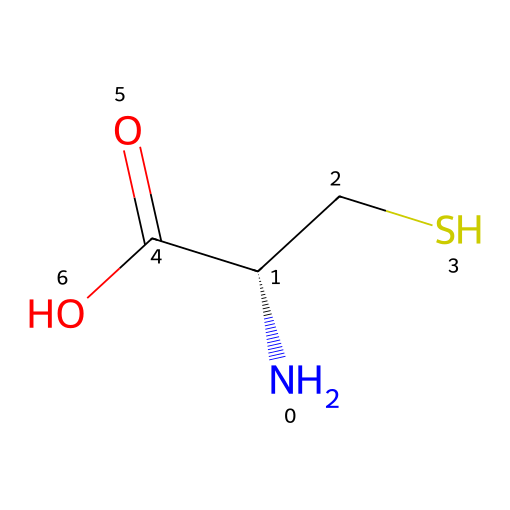How many carbon atoms are present in cysteine? The SMILES representation shows the structure, and by identifying the carbon atoms (C) in the string "N[C@@H](CS)C(=O)O," we can see three distinct carbon atoms present in the structure.
Answer: three What functional groups are present in cysteine? By analyzing the SMILES, we find the presence of a carboxylic acid (-COOH) indicated by "C(=O)O," an amino group (-NH2) indicated by "N," and a thiol group (-SH) indicated by "CS." Therefore, the functional groups are amino, carboxylic acid, and thiol.
Answer: amino, carboxylic acid, thiol What is the stereochemistry of the cysteine molecule? The "C@@H" part of the SMILES indicates that there is a specific stereocenter at that carbon atom, and the "@@" signifies that it has an S (sinister) configuration, indicating the specific spatial arrangement of atoms around that carbon.
Answer: S configuration How many hydrogen atoms are in cysteine? In the SMILES structure, we can tally the implicit hydrogen atoms associated with each non-metal atom: the amino group contributes three, the carbon backbone contributes five more, and the thiol group adds one, resulting in a total of nine hydrogen atoms in cysteine.
Answer: nine Which feature of cysteine allows it to form disulfide bonds? The presence of the thiol group (–SH) is crucial here; this sulfur-containing functional group can react with another thiol group from another cysteine molecule, resulting in the formation of a disulfide bond (-S-S-), which is essential for protein structure stabilization.
Answer: thiol group What type of amino acid is cysteine classified as? Cysteine is classified as a polar, hydrophilic amino acid owing to its sulfhydryl (–SH) functional group, which can form hydrogen bonds with water due to its tendency to interact with polar solvents.
Answer: polar, hydrophilic 